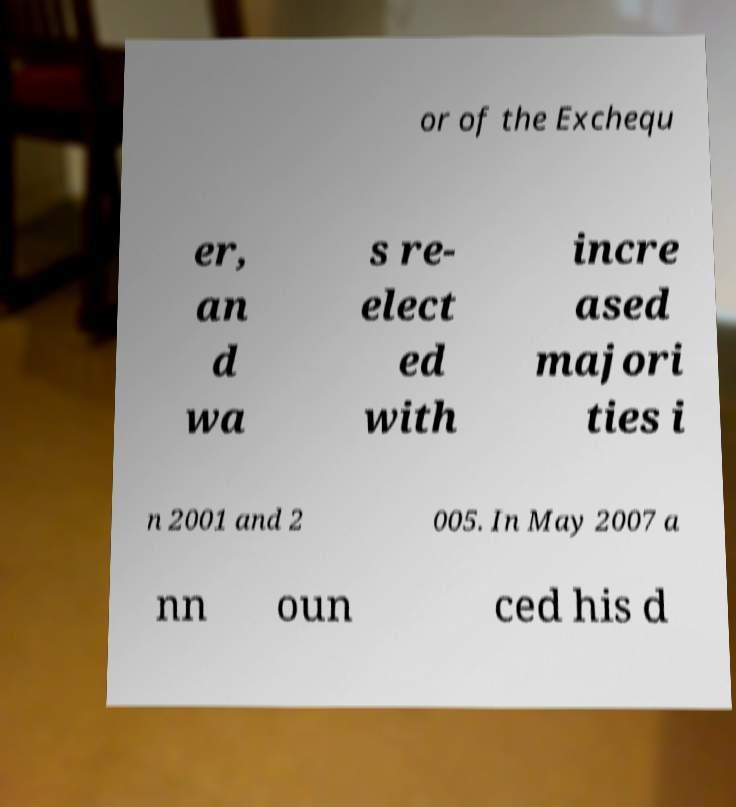Please read and relay the text visible in this image. What does it say? or of the Exchequ er, an d wa s re- elect ed with incre ased majori ties i n 2001 and 2 005. In May 2007 a nn oun ced his d 